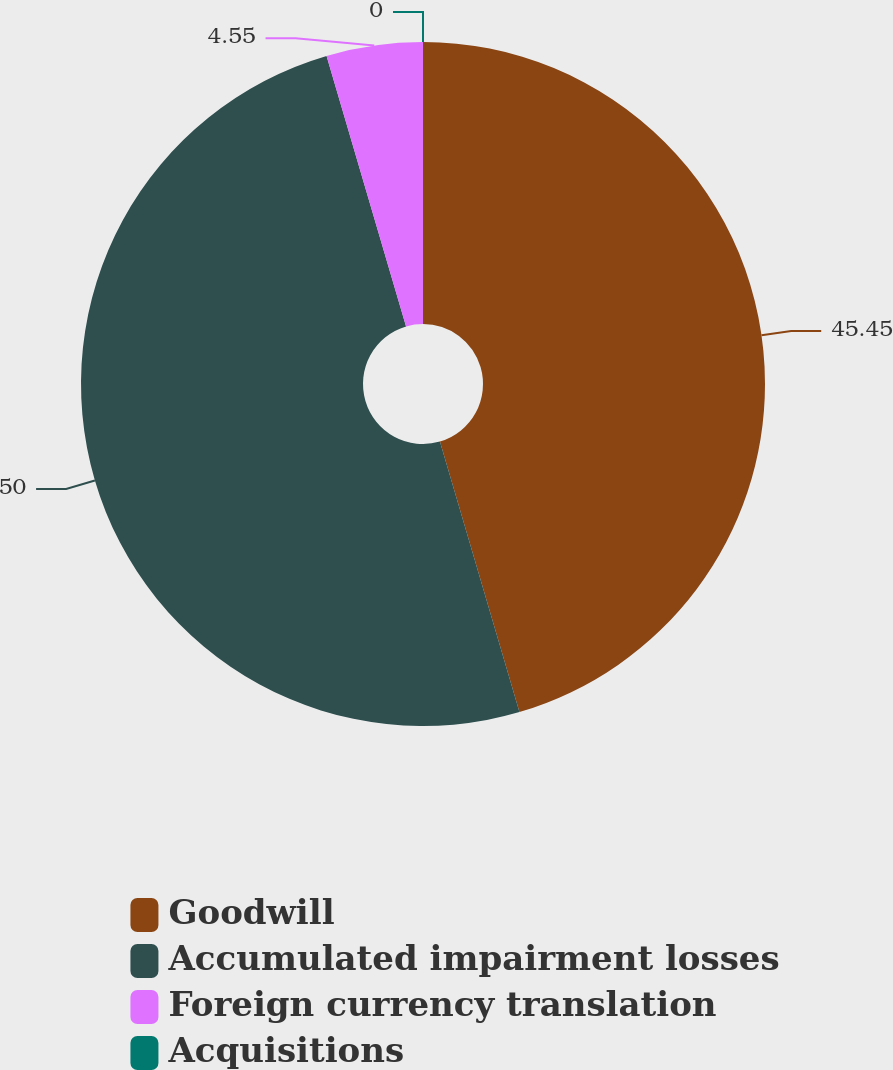<chart> <loc_0><loc_0><loc_500><loc_500><pie_chart><fcel>Goodwill<fcel>Accumulated impairment losses<fcel>Foreign currency translation<fcel>Acquisitions<nl><fcel>45.45%<fcel>50.0%<fcel>4.55%<fcel>0.0%<nl></chart> 